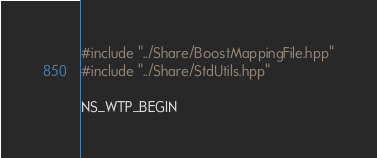<code> <loc_0><loc_0><loc_500><loc_500><_C_>
#include "../Share/BoostMappingFile.hpp"
#include "../Share/StdUtils.hpp"

NS_WTP_BEGIN</code> 